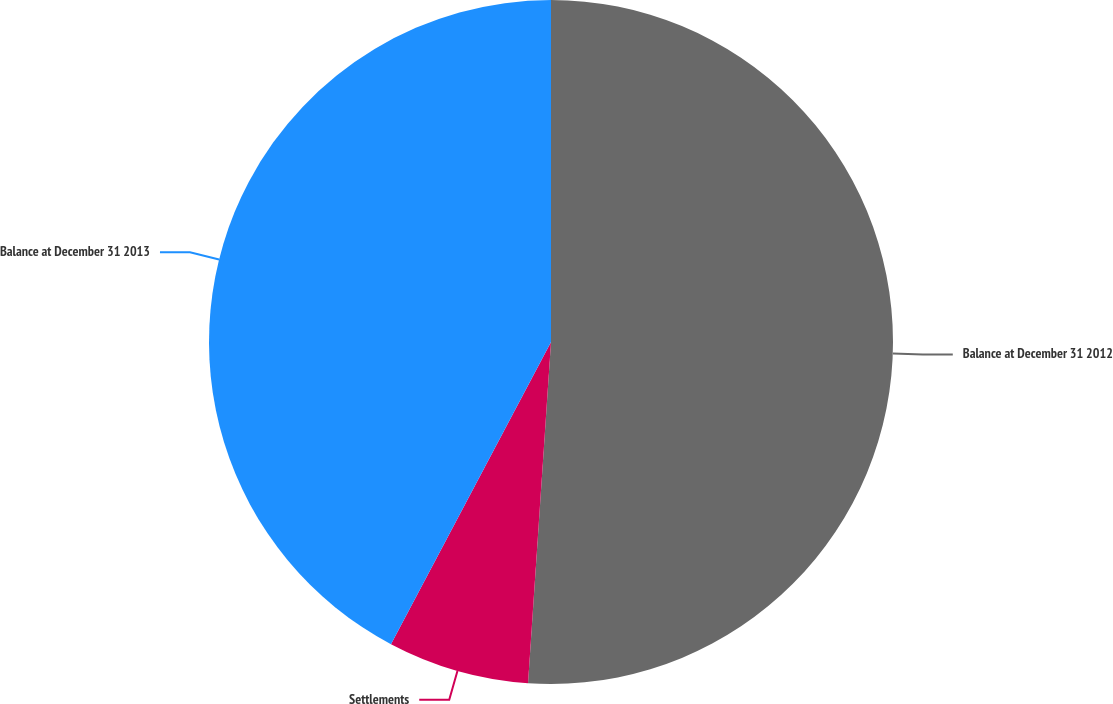Convert chart to OTSL. <chart><loc_0><loc_0><loc_500><loc_500><pie_chart><fcel>Balance at December 31 2012<fcel>Settlements<fcel>Balance at December 31 2013<nl><fcel>51.07%<fcel>6.68%<fcel>42.25%<nl></chart> 